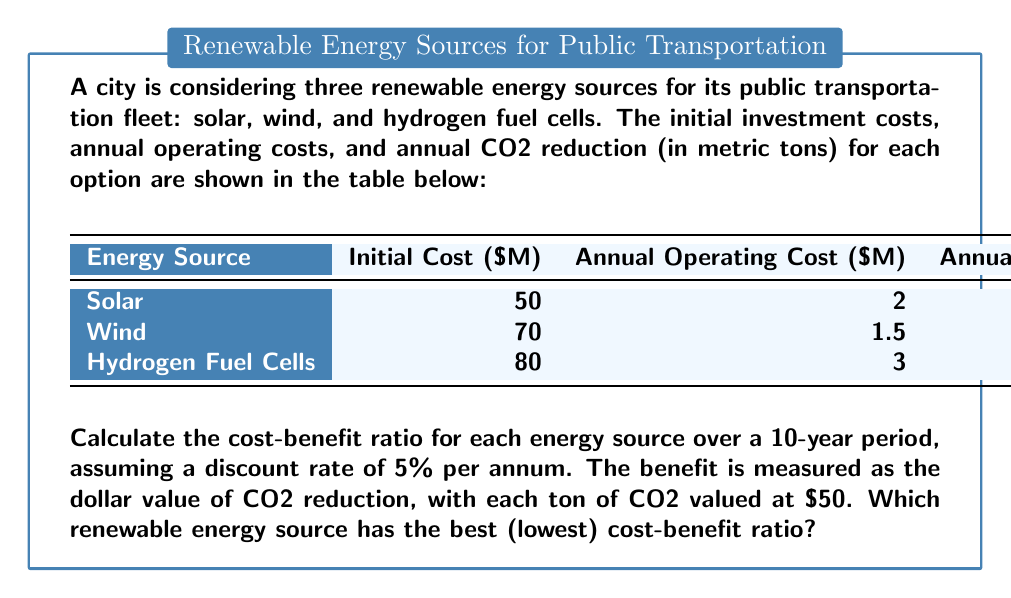Show me your answer to this math problem. To solve this problem, we need to follow these steps:

1) Calculate the Present Value (PV) of costs for each energy source over 10 years:
   PV of Costs = Initial Cost + PV of Annual Operating Costs

   PV of Annual Operating Costs = Annual Cost * Present Value Annuity Factor (PVAF)
   PVAF for 10 years at 5% = $\frac{1-(1+0.05)^{-10}}{0.05}$ = 7.7217

2) Calculate the total CO2 reduction benefit over 10 years for each source:
   Total Benefit = Annual CO2 Reduction * 10 years * $50/ton

3) Calculate the cost-benefit ratio:
   Cost-Benefit Ratio = PV of Costs / Total Benefit

For Solar:
PV of Costs = $50M + ($2M * 7.7217) = $65.4434M
Total Benefit = 15,000 tons * 10 * $50 = $7.5M
Cost-Benefit Ratio = $65.4434M / $7.5M = 8.7258

For Wind:
PV of Costs = $70M + ($1.5M * 7.7217) = $81.5826M
Total Benefit = 20,000 tons * 10 * $50 = $10M
Cost-Benefit Ratio = $81.5826M / $10M = 8.1583

For Hydrogen Fuel Cells:
PV of Costs = $80M + ($3M * 7.7217) = $103.1651M
Total Benefit = 25,000 tons * 10 * $50 = $12.5M
Cost-Benefit Ratio = $103.1651M / $12.5M = 8.2532

The energy source with the lowest cost-benefit ratio is the most economical choice.
Answer: Wind energy, with a cost-benefit ratio of 8.1583. 